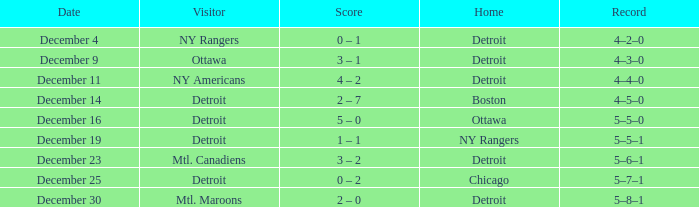What visitor has December 14 as the date? Detroit. 